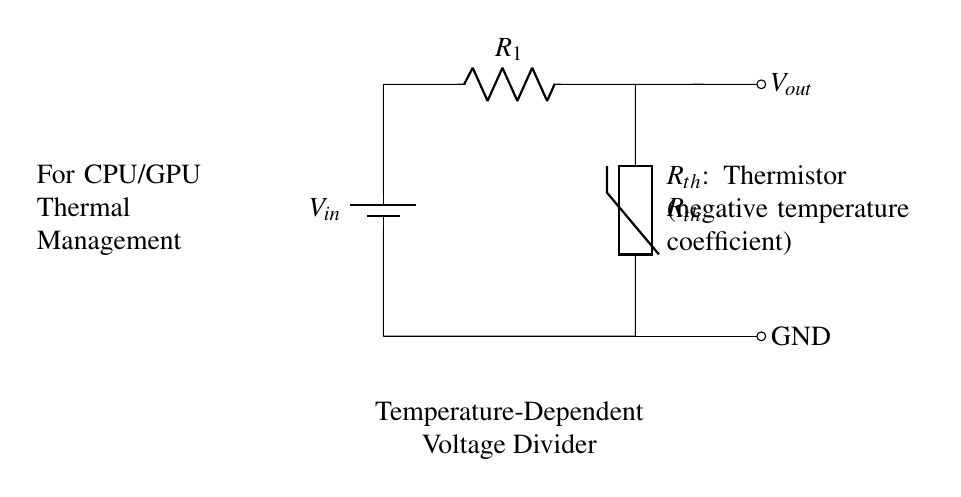What is the input voltage of this circuit? The input voltage is represented by \( V_{in} \), which is labeled on the battery in the diagram. The exact value is not specified, but the label indicates it is the voltage source for the circuit.
Answer: \( V_{in} \) What type of resistor is used in this circuit? The circuit includes a thermistor labeled as \( R_{th} \). A thermistor is a temperature-dependent resistor, which in this case is noted to have a negative temperature coefficient (NTC). This means its resistance decreases as the temperature increases.
Answer: thermistor How many resistors are in the voltage divider? The circuit features two resistors: \( R_1 \) and \( R_{th} \). Together, these form the voltage divider configuration.
Answer: 2 What does \( V_{out} \) represent? \( V_{out} \) represents the output voltage of the voltage divider circuit. It is taken from the node connecting \( R_1 \) and \( R_{th} \) and signifies the voltage drop across \( R_{th} \).
Answer: output voltage Explain how temperature affects \( R_{th} \) in this circuit. In this circuit, \( R_{th} \) is a thermistor with a negative temperature coefficient. Thus, as the temperature increases, the resistance of \( R_{th} \) decreases. This change in resistance affects the output voltage \( V_{out} \), lowering it as temperature increases, which is used for thermal management of CPU and GPU components.
Answer: decreases What is the primary purpose of this voltage divider configuration? This voltage divider is intended for thermal management of CPU and GPU components by adjusting the output voltage based on temperature changes detected by the thermistor. This feedback can be vital for controlling fans or other cooling mechanisms.
Answer: thermal management 